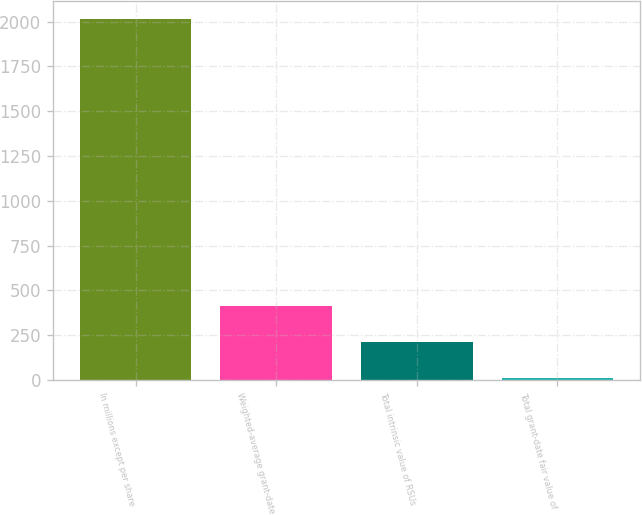Convert chart to OTSL. <chart><loc_0><loc_0><loc_500><loc_500><bar_chart><fcel>In millions except per share<fcel>Weighted-average grant-date<fcel>Total intrinsic value of RSUs<fcel>Total grant-date fair value of<nl><fcel>2013<fcel>413.32<fcel>213.36<fcel>13.4<nl></chart> 